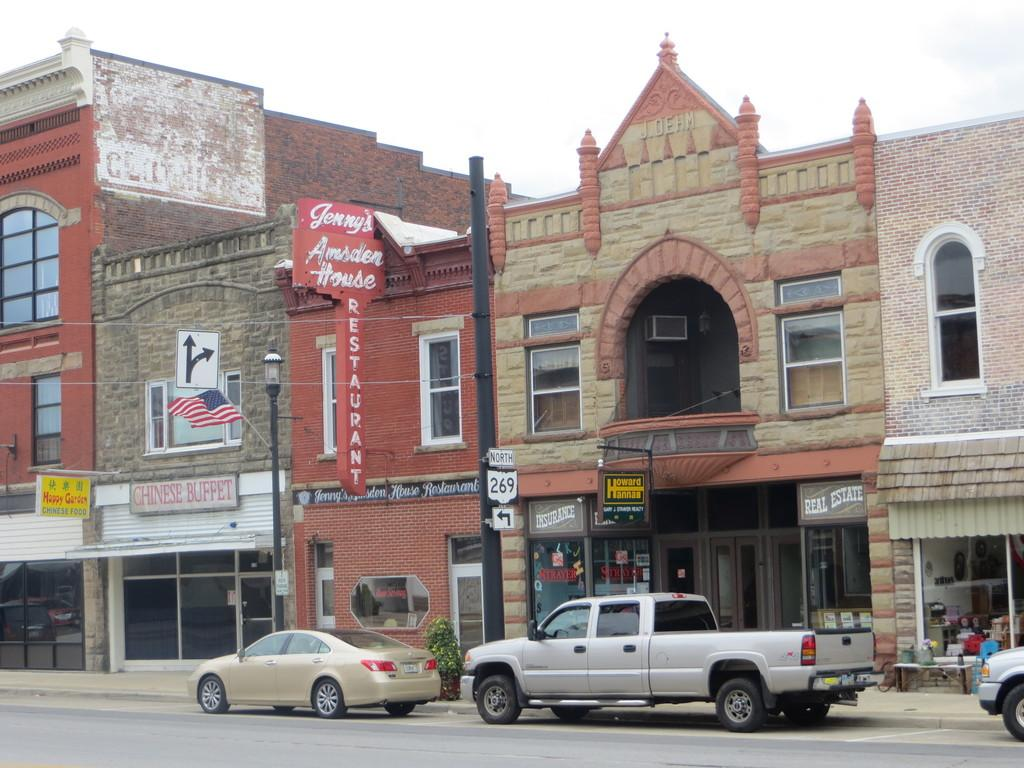What can be seen on the road in the image? There are cars on the road in the image. What type of structures are visible in the image? There are buildings with windows in the image. What type of vegetation is present in the image? There are plants in the image. What type of signs are present in the image? Name boards are present in the image. What type of vertical structures are visible in the image? Flagpoles are visible in the image. What else can be seen in the image besides the mentioned objects? There are other objects in the image. What is visible in the background of the image? The sky is visible in the background of the image. Can you tell me how many birds are flying over the buildings in the image? There are no birds visible in the image. What type of writing is present on the name boards in the image? There is no writing visible on the name boards in the image. 